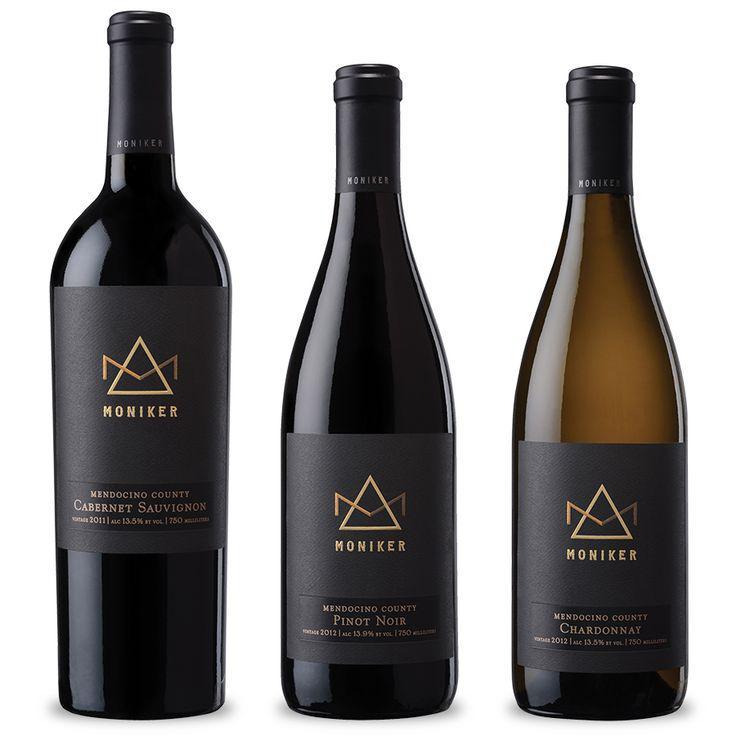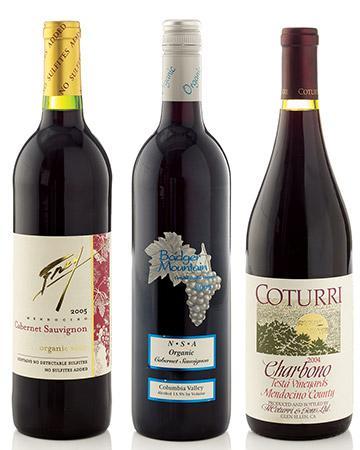The first image is the image on the left, the second image is the image on the right. Analyze the images presented: Is the assertion "There are three wine bottles against a plain white background in each image." valid? Answer yes or no. Yes. The first image is the image on the left, the second image is the image on the right. Analyze the images presented: Is the assertion "The three bottles in each image all different, but one set of three all have the same label, while one set has different labels." valid? Answer yes or no. Yes. The first image is the image on the left, the second image is the image on the right. Examine the images to the left and right. Is the description "An image shows a horizontal row of exactly three wine bottles, and the bottle on the left has a gold wrap over the cap." accurate? Answer yes or no. Yes. 